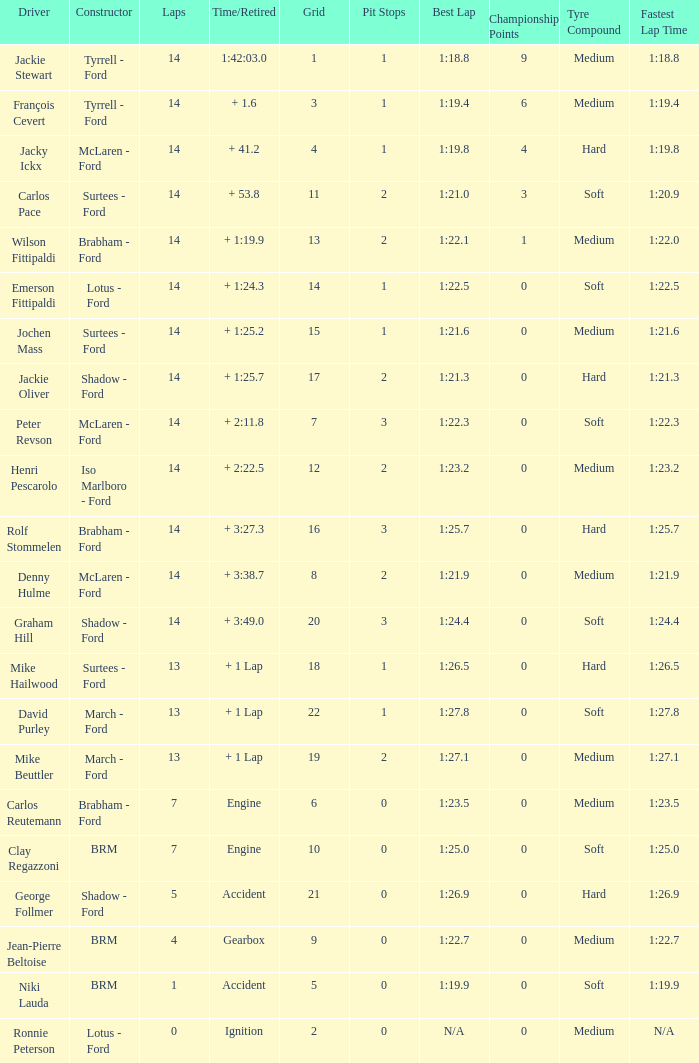Give me the full table as a dictionary. {'header': ['Driver', 'Constructor', 'Laps', 'Time/Retired', 'Grid', 'Pit Stops', 'Best Lap', 'Championship Points', 'Tyre Compound', 'Fastest Lap Time'], 'rows': [['Jackie Stewart', 'Tyrrell - Ford', '14', '1:42:03.0', '1', '1', '1:18.8', '9', 'Medium', '1:18.8'], ['François Cevert', 'Tyrrell - Ford', '14', '+ 1.6', '3', '1', '1:19.4', '6', 'Medium', '1:19.4'], ['Jacky Ickx', 'McLaren - Ford', '14', '+ 41.2', '4', '1', '1:19.8', '4', 'Hard', '1:19.8'], ['Carlos Pace', 'Surtees - Ford', '14', '+ 53.8', '11', '2', '1:21.0', '3', 'Soft', '1:20.9'], ['Wilson Fittipaldi', 'Brabham - Ford', '14', '+ 1:19.9', '13', '2', '1:22.1', '1', 'Medium', '1:22.0'], ['Emerson Fittipaldi', 'Lotus - Ford', '14', '+ 1:24.3', '14', '1', '1:22.5', '0', 'Soft', '1:22.5'], ['Jochen Mass', 'Surtees - Ford', '14', '+ 1:25.2', '15', '1', '1:21.6', '0', 'Medium', '1:21.6'], ['Jackie Oliver', 'Shadow - Ford', '14', '+ 1:25.7', '17', '2', '1:21.3', '0', 'Hard', '1:21.3'], ['Peter Revson', 'McLaren - Ford', '14', '+ 2:11.8', '7', '3', '1:22.3', '0', 'Soft', '1:22.3'], ['Henri Pescarolo', 'Iso Marlboro - Ford', '14', '+ 2:22.5', '12', '2', '1:23.2', '0', 'Medium', '1:23.2'], ['Rolf Stommelen', 'Brabham - Ford', '14', '+ 3:27.3', '16', '3', '1:25.7', '0', 'Hard', '1:25.7'], ['Denny Hulme', 'McLaren - Ford', '14', '+ 3:38.7', '8', '2', '1:21.9', '0', 'Medium', '1:21.9'], ['Graham Hill', 'Shadow - Ford', '14', '+ 3:49.0', '20', '3', '1:24.4', '0', 'Soft', '1:24.4'], ['Mike Hailwood', 'Surtees - Ford', '13', '+ 1 Lap', '18', '1', '1:26.5', '0', 'Hard', '1:26.5'], ['David Purley', 'March - Ford', '13', '+ 1 Lap', '22', '1', '1:27.8', '0', 'Soft', '1:27.8'], ['Mike Beuttler', 'March - Ford', '13', '+ 1 Lap', '19', '2', '1:27.1', '0', 'Medium', '1:27.1'], ['Carlos Reutemann', 'Brabham - Ford', '7', 'Engine', '6', '0', '1:23.5', '0', 'Medium', '1:23.5'], ['Clay Regazzoni', 'BRM', '7', 'Engine', '10', '0', '1:25.0', '0', 'Soft', '1:25.0'], ['George Follmer', 'Shadow - Ford', '5', 'Accident', '21', '0', '1:26.9', '0', 'Hard', '1:26.9'], ['Jean-Pierre Beltoise', 'BRM', '4', 'Gearbox', '9', '0', '1:22.7', '0', 'Medium', '1:22.7'], ['Niki Lauda', 'BRM', '1', 'Accident', '5', '0', '1:19.9', '0', 'Soft', '1:19.9'], ['Ronnie Peterson', 'Lotus - Ford', '0', 'Ignition', '2', '0', 'N/A', '0', 'Medium', 'N/A']]} What is the low lap total for a grid larger than 16 and has a Time/Retired of + 3:27.3? None. 